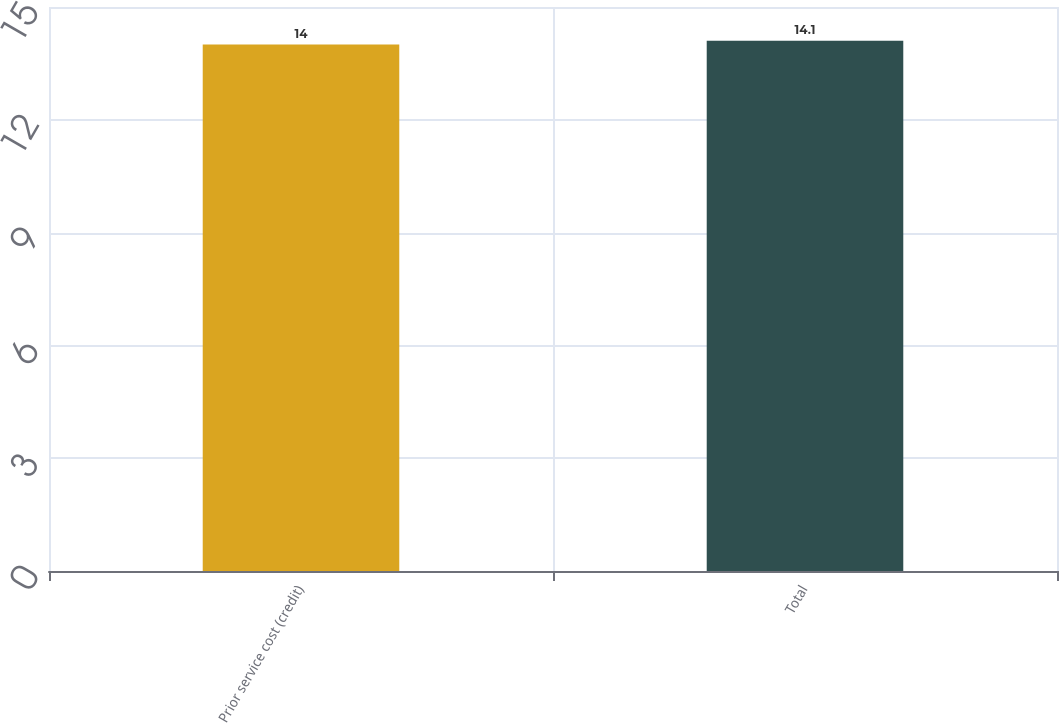Convert chart to OTSL. <chart><loc_0><loc_0><loc_500><loc_500><bar_chart><fcel>Prior service cost (credit)<fcel>Total<nl><fcel>14<fcel>14.1<nl></chart> 